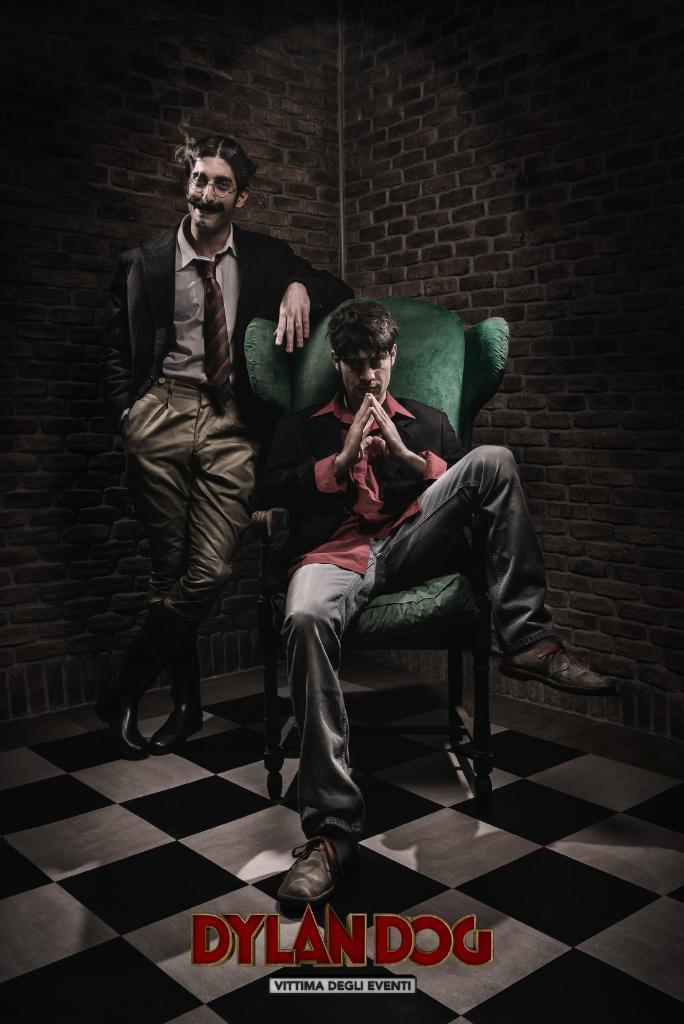Please provide a concise description of this image. In the image we can see two men wearing clothes and shoes. One man is sitting on the chair and the other one is standing and he is wearing spectacles. This is a floor, text and a brick wall. 